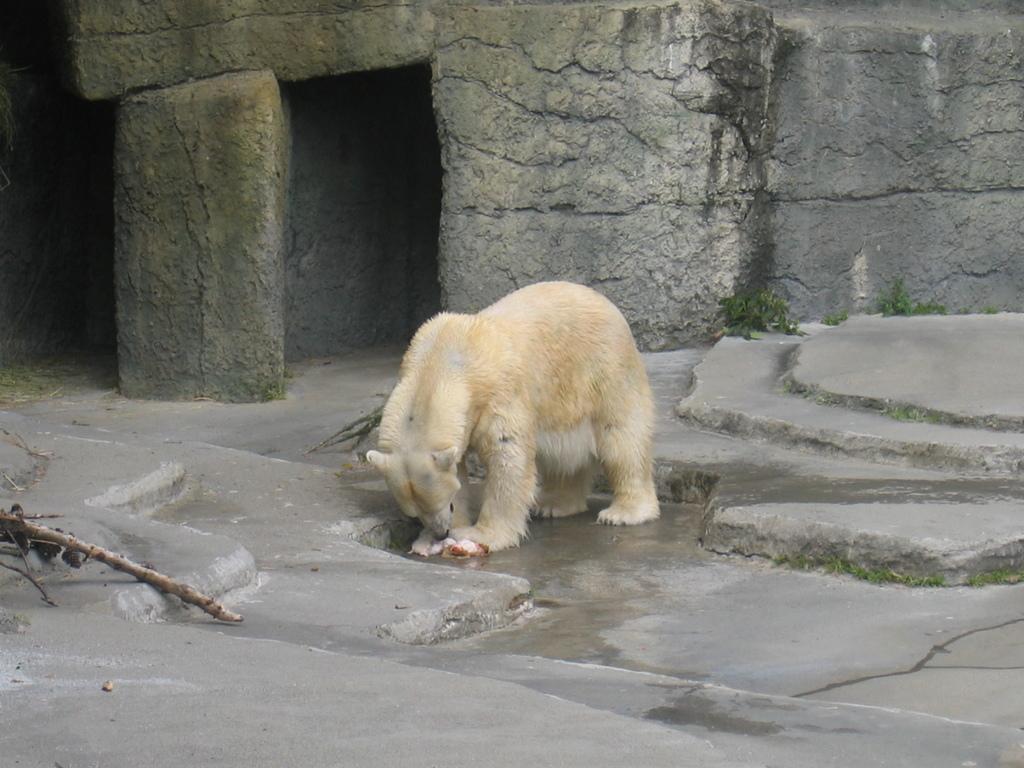Describe this image in one or two sentences. In this image we can see there is a dog standing on the ground. And at the back there is a wall and there is a branch of a tree. 